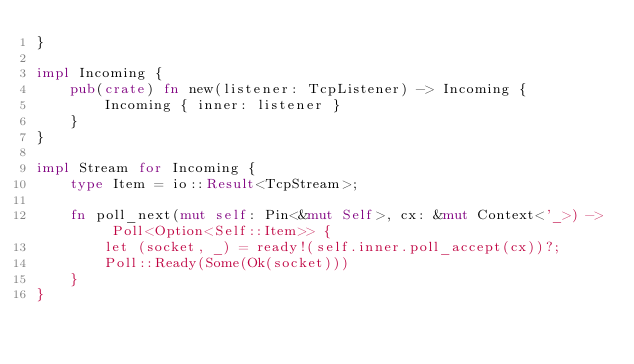<code> <loc_0><loc_0><loc_500><loc_500><_Rust_>}

impl Incoming {
    pub(crate) fn new(listener: TcpListener) -> Incoming {
        Incoming { inner: listener }
    }
}

impl Stream for Incoming {
    type Item = io::Result<TcpStream>;

    fn poll_next(mut self: Pin<&mut Self>, cx: &mut Context<'_>) -> Poll<Option<Self::Item>> {
        let (socket, _) = ready!(self.inner.poll_accept(cx))?;
        Poll::Ready(Some(Ok(socket)))
    }
}
</code> 